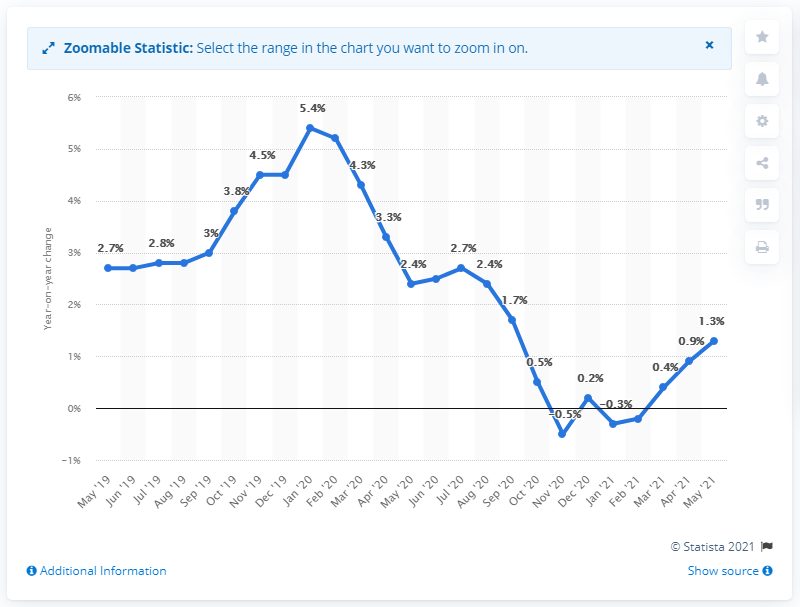Point out several critical features in this image. In May 2021, the inflation rate was 0.9%. In January 2020, the inflation rate was 5.4%. The monthly inflation rate in China in May 2021 was 1.3%. 